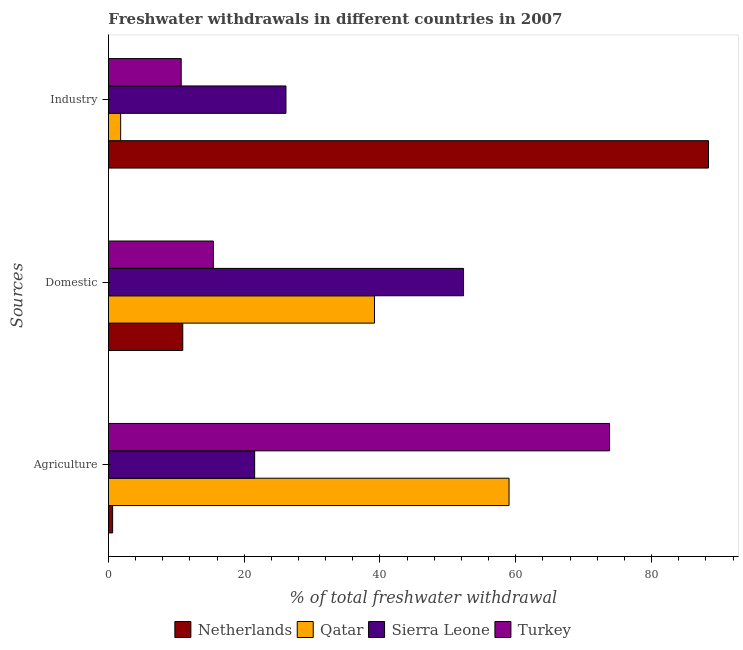How many groups of bars are there?
Your response must be concise. 3. Are the number of bars per tick equal to the number of legend labels?
Ensure brevity in your answer.  Yes. How many bars are there on the 1st tick from the bottom?
Your response must be concise. 4. What is the label of the 3rd group of bars from the top?
Provide a succinct answer. Agriculture. What is the percentage of freshwater withdrawal for industry in Turkey?
Provide a succinct answer. 10.72. Across all countries, what is the maximum percentage of freshwater withdrawal for domestic purposes?
Ensure brevity in your answer.  52.31. Across all countries, what is the minimum percentage of freshwater withdrawal for domestic purposes?
Offer a terse response. 10.95. In which country was the percentage of freshwater withdrawal for domestic purposes maximum?
Give a very brief answer. Sierra Leone. In which country was the percentage of freshwater withdrawal for domestic purposes minimum?
Give a very brief answer. Netherlands. What is the total percentage of freshwater withdrawal for industry in the graph?
Your answer should be compact. 127.06. What is the difference between the percentage of freshwater withdrawal for agriculture in Qatar and that in Netherlands?
Give a very brief answer. 58.39. What is the difference between the percentage of freshwater withdrawal for domestic purposes in Netherlands and the percentage of freshwater withdrawal for industry in Turkey?
Offer a terse response. 0.23. What is the average percentage of freshwater withdrawal for agriculture per country?
Offer a terse response. 38.75. What is the difference between the percentage of freshwater withdrawal for industry and percentage of freshwater withdrawal for agriculture in Sierra Leone?
Make the answer very short. 4.61. What is the ratio of the percentage of freshwater withdrawal for domestic purposes in Sierra Leone to that in Turkey?
Your response must be concise. 3.38. Is the percentage of freshwater withdrawal for industry in Netherlands less than that in Turkey?
Make the answer very short. No. Is the difference between the percentage of freshwater withdrawal for industry in Qatar and Netherlands greater than the difference between the percentage of freshwater withdrawal for domestic purposes in Qatar and Netherlands?
Provide a succinct answer. No. What is the difference between the highest and the second highest percentage of freshwater withdrawal for agriculture?
Make the answer very short. 14.81. What is the difference between the highest and the lowest percentage of freshwater withdrawal for agriculture?
Your answer should be compact. 73.2. In how many countries, is the percentage of freshwater withdrawal for agriculture greater than the average percentage of freshwater withdrawal for agriculture taken over all countries?
Make the answer very short. 2. What does the 1st bar from the bottom in Domestic represents?
Provide a short and direct response. Netherlands. How many bars are there?
Provide a succinct answer. 12. Are all the bars in the graph horizontal?
Offer a very short reply. Yes. What is the difference between two consecutive major ticks on the X-axis?
Provide a short and direct response. 20. Does the graph contain any zero values?
Provide a short and direct response. No. Does the graph contain grids?
Your answer should be very brief. No. Where does the legend appear in the graph?
Make the answer very short. Bottom center. How are the legend labels stacked?
Provide a succinct answer. Horizontal. What is the title of the graph?
Provide a succinct answer. Freshwater withdrawals in different countries in 2007. Does "Caribbean small states" appear as one of the legend labels in the graph?
Your answer should be very brief. No. What is the label or title of the X-axis?
Your answer should be very brief. % of total freshwater withdrawal. What is the label or title of the Y-axis?
Give a very brief answer. Sources. What is the % of total freshwater withdrawal of Netherlands in Agriculture?
Your answer should be compact. 0.62. What is the % of total freshwater withdrawal of Qatar in Agriculture?
Your answer should be very brief. 59.01. What is the % of total freshwater withdrawal of Sierra Leone in Agriculture?
Your answer should be very brief. 21.54. What is the % of total freshwater withdrawal of Turkey in Agriculture?
Your response must be concise. 73.82. What is the % of total freshwater withdrawal of Netherlands in Domestic?
Give a very brief answer. 10.95. What is the % of total freshwater withdrawal of Qatar in Domestic?
Keep it short and to the point. 39.19. What is the % of total freshwater withdrawal of Sierra Leone in Domestic?
Offer a very short reply. 52.31. What is the % of total freshwater withdrawal in Turkey in Domestic?
Offer a terse response. 15.46. What is the % of total freshwater withdrawal in Netherlands in Industry?
Your answer should be compact. 88.39. What is the % of total freshwater withdrawal in Qatar in Industry?
Keep it short and to the point. 1.8. What is the % of total freshwater withdrawal of Sierra Leone in Industry?
Ensure brevity in your answer.  26.15. What is the % of total freshwater withdrawal of Turkey in Industry?
Keep it short and to the point. 10.72. Across all Sources, what is the maximum % of total freshwater withdrawal of Netherlands?
Provide a short and direct response. 88.39. Across all Sources, what is the maximum % of total freshwater withdrawal of Qatar?
Keep it short and to the point. 59.01. Across all Sources, what is the maximum % of total freshwater withdrawal in Sierra Leone?
Keep it short and to the point. 52.31. Across all Sources, what is the maximum % of total freshwater withdrawal of Turkey?
Your answer should be compact. 73.82. Across all Sources, what is the minimum % of total freshwater withdrawal of Netherlands?
Offer a very short reply. 0.62. Across all Sources, what is the minimum % of total freshwater withdrawal of Qatar?
Provide a succinct answer. 1.8. Across all Sources, what is the minimum % of total freshwater withdrawal in Sierra Leone?
Your response must be concise. 21.54. Across all Sources, what is the minimum % of total freshwater withdrawal in Turkey?
Offer a terse response. 10.72. What is the total % of total freshwater withdrawal of Netherlands in the graph?
Your answer should be compact. 99.96. What is the total % of total freshwater withdrawal of Qatar in the graph?
Offer a very short reply. 100. What is the total % of total freshwater withdrawal in Sierra Leone in the graph?
Make the answer very short. 100. What is the total % of total freshwater withdrawal in Turkey in the graph?
Offer a very short reply. 100. What is the difference between the % of total freshwater withdrawal of Netherlands in Agriculture and that in Domestic?
Keep it short and to the point. -10.33. What is the difference between the % of total freshwater withdrawal in Qatar in Agriculture and that in Domestic?
Provide a short and direct response. 19.82. What is the difference between the % of total freshwater withdrawal of Sierra Leone in Agriculture and that in Domestic?
Provide a succinct answer. -30.77. What is the difference between the % of total freshwater withdrawal of Turkey in Agriculture and that in Domestic?
Provide a succinct answer. 58.36. What is the difference between the % of total freshwater withdrawal of Netherlands in Agriculture and that in Industry?
Offer a terse response. -87.77. What is the difference between the % of total freshwater withdrawal in Qatar in Agriculture and that in Industry?
Keep it short and to the point. 57.21. What is the difference between the % of total freshwater withdrawal in Sierra Leone in Agriculture and that in Industry?
Provide a short and direct response. -4.61. What is the difference between the % of total freshwater withdrawal of Turkey in Agriculture and that in Industry?
Offer a very short reply. 63.1. What is the difference between the % of total freshwater withdrawal in Netherlands in Domestic and that in Industry?
Your answer should be compact. -77.44. What is the difference between the % of total freshwater withdrawal in Qatar in Domestic and that in Industry?
Ensure brevity in your answer.  37.39. What is the difference between the % of total freshwater withdrawal of Sierra Leone in Domestic and that in Industry?
Provide a short and direct response. 26.16. What is the difference between the % of total freshwater withdrawal in Turkey in Domestic and that in Industry?
Give a very brief answer. 4.74. What is the difference between the % of total freshwater withdrawal in Netherlands in Agriculture and the % of total freshwater withdrawal in Qatar in Domestic?
Ensure brevity in your answer.  -38.57. What is the difference between the % of total freshwater withdrawal of Netherlands in Agriculture and the % of total freshwater withdrawal of Sierra Leone in Domestic?
Make the answer very short. -51.69. What is the difference between the % of total freshwater withdrawal of Netherlands in Agriculture and the % of total freshwater withdrawal of Turkey in Domestic?
Your response must be concise. -14.84. What is the difference between the % of total freshwater withdrawal of Qatar in Agriculture and the % of total freshwater withdrawal of Turkey in Domestic?
Make the answer very short. 43.55. What is the difference between the % of total freshwater withdrawal of Sierra Leone in Agriculture and the % of total freshwater withdrawal of Turkey in Domestic?
Make the answer very short. 6.08. What is the difference between the % of total freshwater withdrawal of Netherlands in Agriculture and the % of total freshwater withdrawal of Qatar in Industry?
Your response must be concise. -1.18. What is the difference between the % of total freshwater withdrawal in Netherlands in Agriculture and the % of total freshwater withdrawal in Sierra Leone in Industry?
Offer a very short reply. -25.53. What is the difference between the % of total freshwater withdrawal of Netherlands in Agriculture and the % of total freshwater withdrawal of Turkey in Industry?
Give a very brief answer. -10.1. What is the difference between the % of total freshwater withdrawal in Qatar in Agriculture and the % of total freshwater withdrawal in Sierra Leone in Industry?
Ensure brevity in your answer.  32.86. What is the difference between the % of total freshwater withdrawal in Qatar in Agriculture and the % of total freshwater withdrawal in Turkey in Industry?
Provide a short and direct response. 48.29. What is the difference between the % of total freshwater withdrawal in Sierra Leone in Agriculture and the % of total freshwater withdrawal in Turkey in Industry?
Ensure brevity in your answer.  10.82. What is the difference between the % of total freshwater withdrawal of Netherlands in Domestic and the % of total freshwater withdrawal of Qatar in Industry?
Offer a terse response. 9.15. What is the difference between the % of total freshwater withdrawal in Netherlands in Domestic and the % of total freshwater withdrawal in Sierra Leone in Industry?
Provide a succinct answer. -15.2. What is the difference between the % of total freshwater withdrawal of Netherlands in Domestic and the % of total freshwater withdrawal of Turkey in Industry?
Your answer should be very brief. 0.23. What is the difference between the % of total freshwater withdrawal of Qatar in Domestic and the % of total freshwater withdrawal of Sierra Leone in Industry?
Your response must be concise. 13.04. What is the difference between the % of total freshwater withdrawal of Qatar in Domestic and the % of total freshwater withdrawal of Turkey in Industry?
Ensure brevity in your answer.  28.47. What is the difference between the % of total freshwater withdrawal in Sierra Leone in Domestic and the % of total freshwater withdrawal in Turkey in Industry?
Your answer should be compact. 41.59. What is the average % of total freshwater withdrawal in Netherlands per Sources?
Offer a terse response. 33.32. What is the average % of total freshwater withdrawal in Qatar per Sources?
Provide a succinct answer. 33.33. What is the average % of total freshwater withdrawal of Sierra Leone per Sources?
Offer a terse response. 33.33. What is the average % of total freshwater withdrawal in Turkey per Sources?
Offer a terse response. 33.33. What is the difference between the % of total freshwater withdrawal of Netherlands and % of total freshwater withdrawal of Qatar in Agriculture?
Your answer should be very brief. -58.39. What is the difference between the % of total freshwater withdrawal in Netherlands and % of total freshwater withdrawal in Sierra Leone in Agriculture?
Offer a very short reply. -20.92. What is the difference between the % of total freshwater withdrawal in Netherlands and % of total freshwater withdrawal in Turkey in Agriculture?
Give a very brief answer. -73.2. What is the difference between the % of total freshwater withdrawal in Qatar and % of total freshwater withdrawal in Sierra Leone in Agriculture?
Make the answer very short. 37.47. What is the difference between the % of total freshwater withdrawal of Qatar and % of total freshwater withdrawal of Turkey in Agriculture?
Your response must be concise. -14.81. What is the difference between the % of total freshwater withdrawal of Sierra Leone and % of total freshwater withdrawal of Turkey in Agriculture?
Your answer should be compact. -52.28. What is the difference between the % of total freshwater withdrawal in Netherlands and % of total freshwater withdrawal in Qatar in Domestic?
Make the answer very short. -28.24. What is the difference between the % of total freshwater withdrawal of Netherlands and % of total freshwater withdrawal of Sierra Leone in Domestic?
Offer a very short reply. -41.36. What is the difference between the % of total freshwater withdrawal in Netherlands and % of total freshwater withdrawal in Turkey in Domestic?
Your response must be concise. -4.51. What is the difference between the % of total freshwater withdrawal of Qatar and % of total freshwater withdrawal of Sierra Leone in Domestic?
Give a very brief answer. -13.12. What is the difference between the % of total freshwater withdrawal of Qatar and % of total freshwater withdrawal of Turkey in Domestic?
Offer a terse response. 23.73. What is the difference between the % of total freshwater withdrawal in Sierra Leone and % of total freshwater withdrawal in Turkey in Domestic?
Give a very brief answer. 36.85. What is the difference between the % of total freshwater withdrawal of Netherlands and % of total freshwater withdrawal of Qatar in Industry?
Provide a short and direct response. 86.59. What is the difference between the % of total freshwater withdrawal in Netherlands and % of total freshwater withdrawal in Sierra Leone in Industry?
Offer a terse response. 62.24. What is the difference between the % of total freshwater withdrawal of Netherlands and % of total freshwater withdrawal of Turkey in Industry?
Your response must be concise. 77.67. What is the difference between the % of total freshwater withdrawal in Qatar and % of total freshwater withdrawal in Sierra Leone in Industry?
Your response must be concise. -24.35. What is the difference between the % of total freshwater withdrawal in Qatar and % of total freshwater withdrawal in Turkey in Industry?
Make the answer very short. -8.92. What is the difference between the % of total freshwater withdrawal of Sierra Leone and % of total freshwater withdrawal of Turkey in Industry?
Provide a short and direct response. 15.43. What is the ratio of the % of total freshwater withdrawal of Netherlands in Agriculture to that in Domestic?
Your answer should be very brief. 0.06. What is the ratio of the % of total freshwater withdrawal of Qatar in Agriculture to that in Domestic?
Your answer should be very brief. 1.51. What is the ratio of the % of total freshwater withdrawal in Sierra Leone in Agriculture to that in Domestic?
Your answer should be very brief. 0.41. What is the ratio of the % of total freshwater withdrawal in Turkey in Agriculture to that in Domestic?
Your response must be concise. 4.77. What is the ratio of the % of total freshwater withdrawal in Netherlands in Agriculture to that in Industry?
Provide a short and direct response. 0.01. What is the ratio of the % of total freshwater withdrawal of Qatar in Agriculture to that in Industry?
Give a very brief answer. 32.75. What is the ratio of the % of total freshwater withdrawal of Sierra Leone in Agriculture to that in Industry?
Your answer should be compact. 0.82. What is the ratio of the % of total freshwater withdrawal in Turkey in Agriculture to that in Industry?
Ensure brevity in your answer.  6.89. What is the ratio of the % of total freshwater withdrawal in Netherlands in Domestic to that in Industry?
Keep it short and to the point. 0.12. What is the ratio of the % of total freshwater withdrawal in Qatar in Domestic to that in Industry?
Your answer should be very brief. 21.75. What is the ratio of the % of total freshwater withdrawal in Sierra Leone in Domestic to that in Industry?
Make the answer very short. 2. What is the ratio of the % of total freshwater withdrawal in Turkey in Domestic to that in Industry?
Offer a terse response. 1.44. What is the difference between the highest and the second highest % of total freshwater withdrawal of Netherlands?
Provide a succinct answer. 77.44. What is the difference between the highest and the second highest % of total freshwater withdrawal of Qatar?
Ensure brevity in your answer.  19.82. What is the difference between the highest and the second highest % of total freshwater withdrawal of Sierra Leone?
Provide a succinct answer. 26.16. What is the difference between the highest and the second highest % of total freshwater withdrawal in Turkey?
Make the answer very short. 58.36. What is the difference between the highest and the lowest % of total freshwater withdrawal of Netherlands?
Your answer should be very brief. 87.77. What is the difference between the highest and the lowest % of total freshwater withdrawal in Qatar?
Make the answer very short. 57.21. What is the difference between the highest and the lowest % of total freshwater withdrawal in Sierra Leone?
Ensure brevity in your answer.  30.77. What is the difference between the highest and the lowest % of total freshwater withdrawal of Turkey?
Make the answer very short. 63.1. 